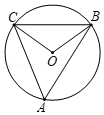If angle A is 50 degrees and points A, B, and C all lie on circle O, what is the value of angle OBC? By geometric principles, angle A at 50 degrees implies that angle BOC is twice that, at 100 degrees, because the angle at the center is twice the angle at the circumference when subtended by the same arc. Since triangle OBC is isosceles with sides BO and CO being radii of the circle, the angles at B and C are equal. These two angles sum to 180 degrees minus the central angle, BOC, giving us 80 degrees to share equally. Thus, each angle, OBC and OCB, measures 40 degrees, confirming that the correct choice is B, 40 degrees. 